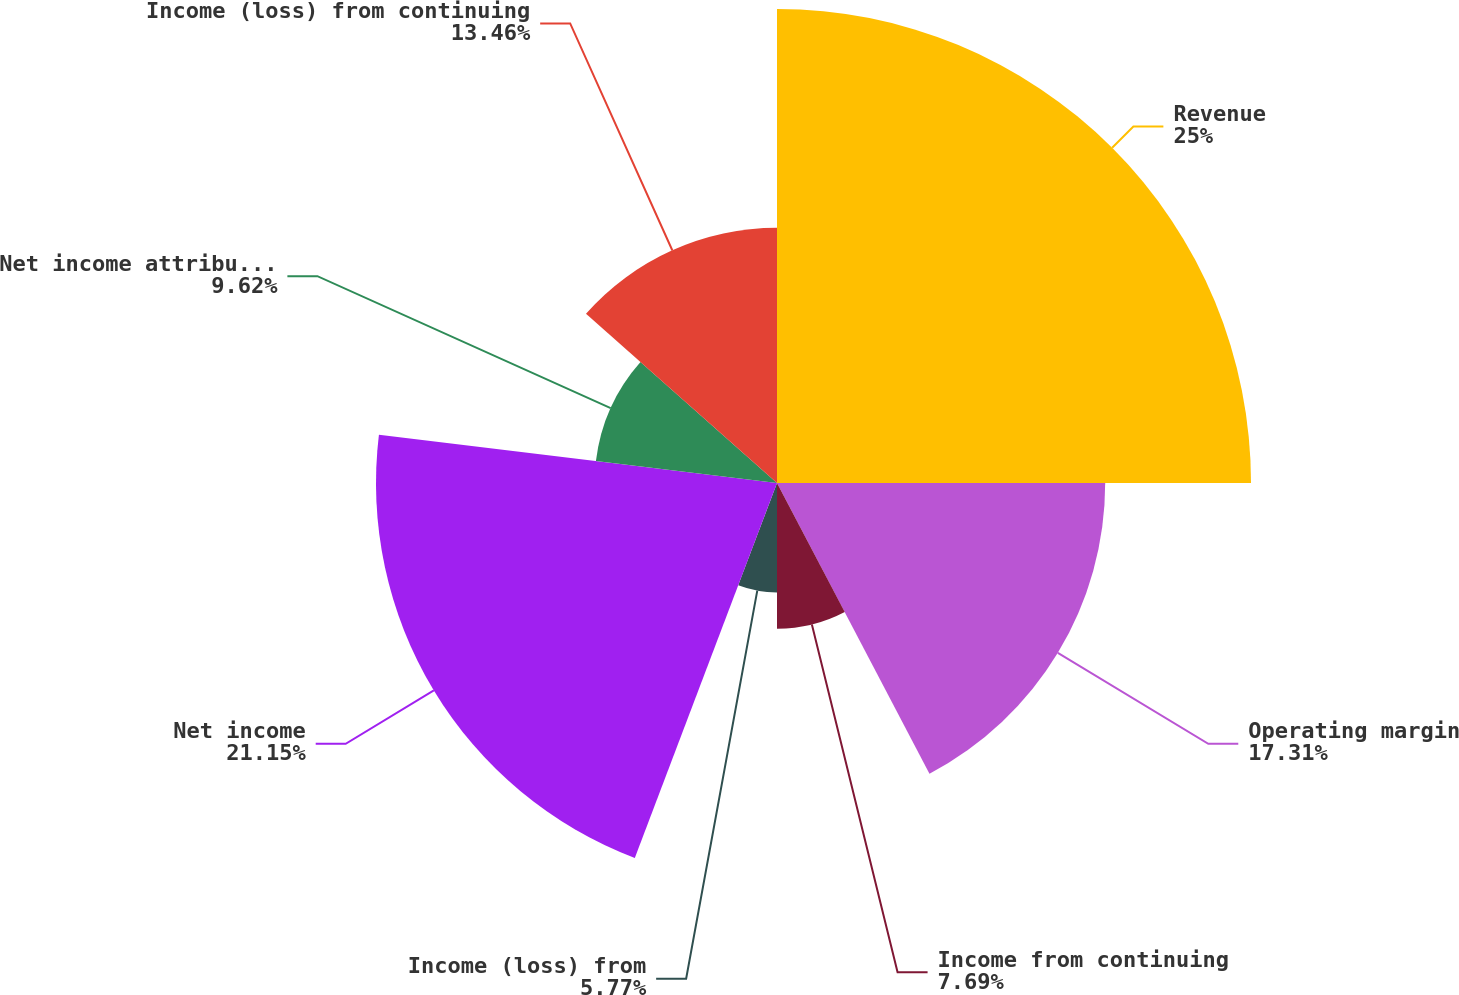Convert chart. <chart><loc_0><loc_0><loc_500><loc_500><pie_chart><fcel>Revenue<fcel>Operating margin<fcel>Income from continuing<fcel>Income (loss) from<fcel>Net income<fcel>Net income attributable to The<fcel>Income (loss) from continuing<nl><fcel>25.0%<fcel>17.31%<fcel>7.69%<fcel>5.77%<fcel>21.15%<fcel>9.62%<fcel>13.46%<nl></chart> 